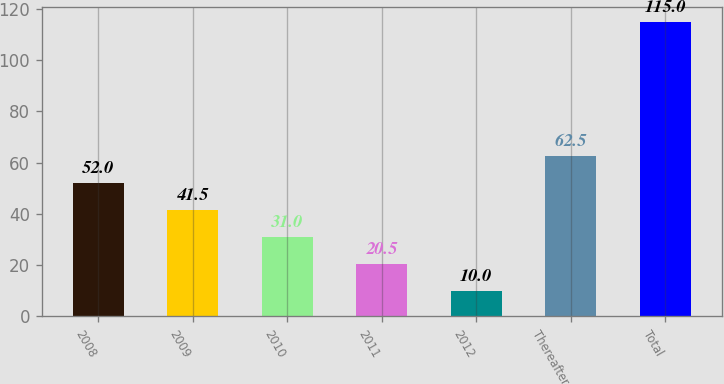Convert chart. <chart><loc_0><loc_0><loc_500><loc_500><bar_chart><fcel>2008<fcel>2009<fcel>2010<fcel>2011<fcel>2012<fcel>Thereafter<fcel>Total<nl><fcel>52<fcel>41.5<fcel>31<fcel>20.5<fcel>10<fcel>62.5<fcel>115<nl></chart> 